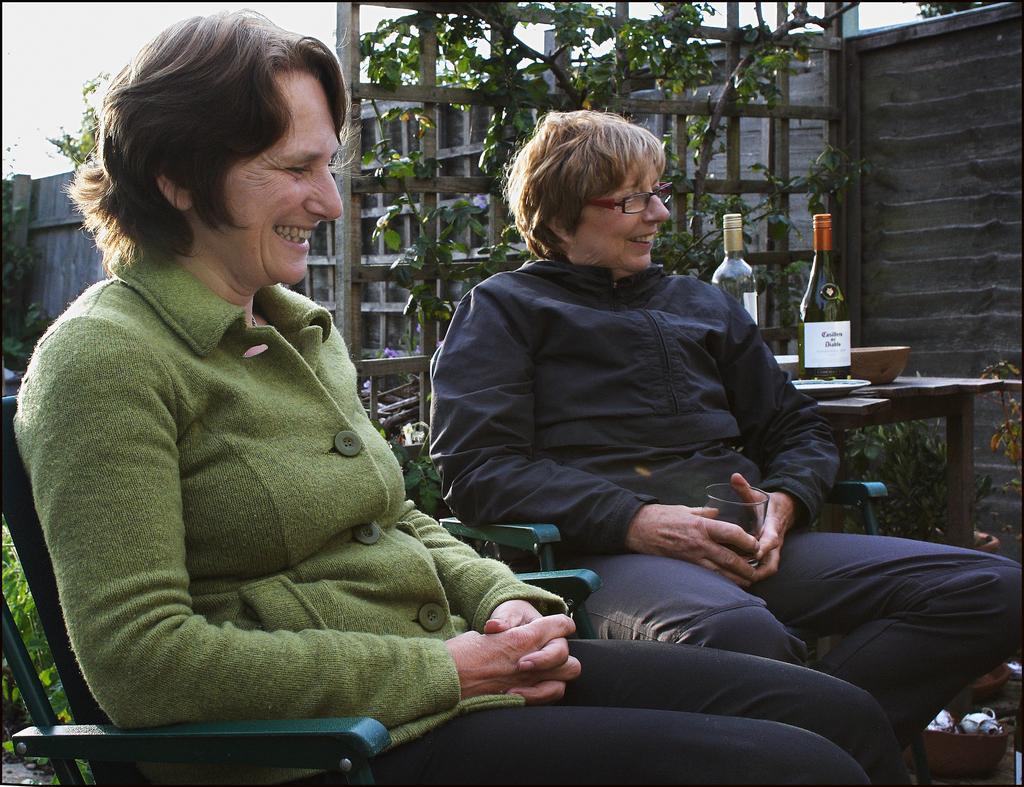Can you describe this image briefly? Here I can see two persons sitting on the chairs facing towards the right side and smiling. At the back of these people there is a table on which a bowl, two bottles and a plate are placed. In the background there is a wall and few plants. At the top I can see the sky. 